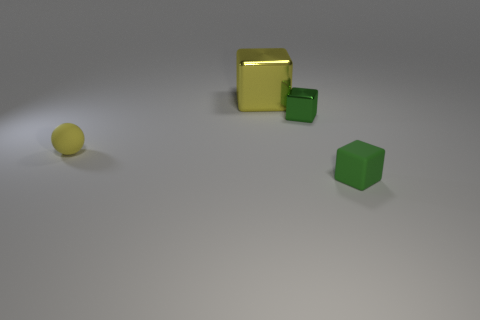What number of small things are the same color as the big block?
Keep it short and to the point. 1. There is a tiny object left of the tiny green block behind the tiny rubber thing left of the large shiny thing; what is it made of?
Offer a terse response. Rubber. What is the color of the tiny object on the left side of the yellow thing behind the tiny yellow ball?
Your response must be concise. Yellow. What number of large things are either yellow blocks or green blocks?
Provide a succinct answer. 1. How many small green cubes are the same material as the big cube?
Your answer should be very brief. 1. There is a yellow object that is on the right side of the tiny matte sphere; what is its size?
Your response must be concise. Large. The tiny green object that is behind the small green block in front of the sphere is what shape?
Your answer should be very brief. Cube. There is a block behind the green metal object that is to the right of the large shiny cube; how many tiny rubber things are on the left side of it?
Your response must be concise. 1. Is the number of small yellow spheres that are to the right of the yellow shiny cube less than the number of large yellow cubes?
Provide a succinct answer. Yes. Are there any other things that have the same shape as the yellow rubber thing?
Give a very brief answer. No. 